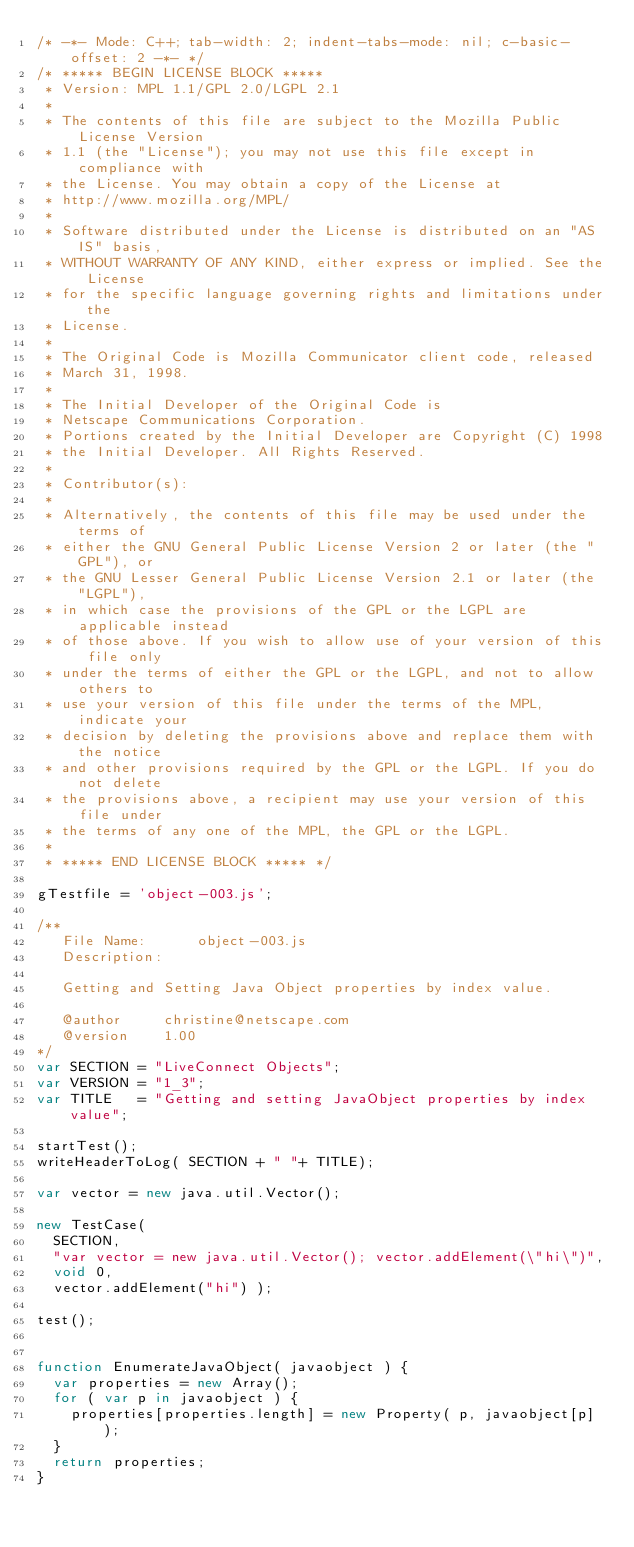<code> <loc_0><loc_0><loc_500><loc_500><_JavaScript_>/* -*- Mode: C++; tab-width: 2; indent-tabs-mode: nil; c-basic-offset: 2 -*- */
/* ***** BEGIN LICENSE BLOCK *****
 * Version: MPL 1.1/GPL 2.0/LGPL 2.1
 *
 * The contents of this file are subject to the Mozilla Public License Version
 * 1.1 (the "License"); you may not use this file except in compliance with
 * the License. You may obtain a copy of the License at
 * http://www.mozilla.org/MPL/
 *
 * Software distributed under the License is distributed on an "AS IS" basis,
 * WITHOUT WARRANTY OF ANY KIND, either express or implied. See the License
 * for the specific language governing rights and limitations under the
 * License.
 *
 * The Original Code is Mozilla Communicator client code, released
 * March 31, 1998.
 *
 * The Initial Developer of the Original Code is
 * Netscape Communications Corporation.
 * Portions created by the Initial Developer are Copyright (C) 1998
 * the Initial Developer. All Rights Reserved.
 *
 * Contributor(s):
 *
 * Alternatively, the contents of this file may be used under the terms of
 * either the GNU General Public License Version 2 or later (the "GPL"), or
 * the GNU Lesser General Public License Version 2.1 or later (the "LGPL"),
 * in which case the provisions of the GPL or the LGPL are applicable instead
 * of those above. If you wish to allow use of your version of this file only
 * under the terms of either the GPL or the LGPL, and not to allow others to
 * use your version of this file under the terms of the MPL, indicate your
 * decision by deleting the provisions above and replace them with the notice
 * and other provisions required by the GPL or the LGPL. If you do not delete
 * the provisions above, a recipient may use your version of this file under
 * the terms of any one of the MPL, the GPL or the LGPL.
 *
 * ***** END LICENSE BLOCK ***** */

gTestfile = 'object-003.js';

/**
   File Name:      object-003.js
   Description:

   Getting and Setting Java Object properties by index value.

   @author     christine@netscape.com
   @version    1.00
*/
var SECTION = "LiveConnect Objects";
var VERSION = "1_3";
var TITLE   = "Getting and setting JavaObject properties by index value";

startTest();
writeHeaderToLog( SECTION + " "+ TITLE);

var vector = new java.util.Vector();

new TestCase(
  SECTION,
  "var vector = new java.util.Vector(); vector.addElement(\"hi\")",
  void 0,
  vector.addElement("hi") );

test();


function EnumerateJavaObject( javaobject ) {
  var properties = new Array();
  for ( var p in javaobject ) {
    properties[properties.length] = new Property( p, javaobject[p] );
  }
  return properties;
}</code> 